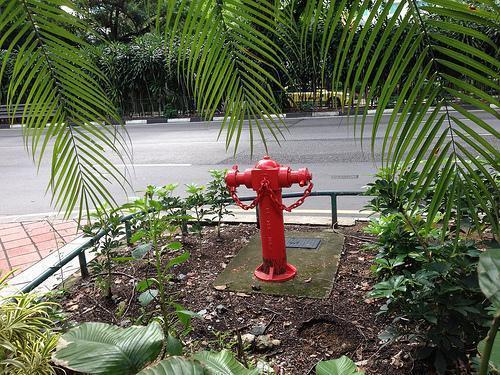How many white portions of curb are visible across the street?
Give a very brief answer. 11. How many hydrants are there?
Give a very brief answer. 1. How many lanes are there in the road?
Give a very brief answer. 4. 